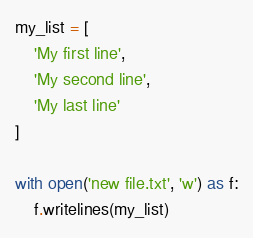<code> <loc_0><loc_0><loc_500><loc_500><_Python_>my_list = [
    'My first line',
    'My second line',
    'My last line'
]

with open('new file.txt', 'w') as f:
    f.writelines(my_list)
</code> 